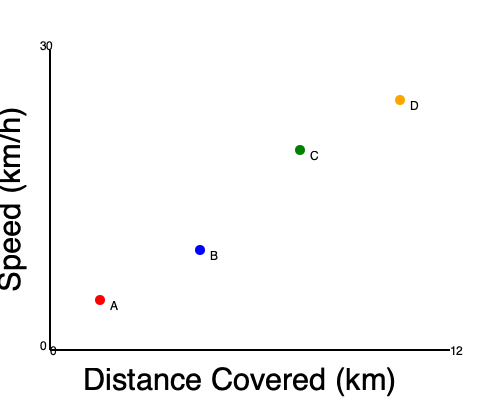Based on the scatter plot showing players' speed vs. distance covered during a match, which player is likely to be a midfielder with high endurance? To determine which player is likely to be a midfielder with high endurance, we need to analyze the relationship between speed and distance covered for each player:

1. Player A: Low speed, low distance covered
2. Player B: Moderate speed, moderate distance covered
3. Player C: High speed, high distance covered
4. Player D: Very high speed, very high distance covered

Midfielders typically need to cover large distances throughout the match while maintaining a good balance of speed. They require high endurance to continually move across the field, supporting both defense and attack.

Player C demonstrates a good balance of high speed and high distance covered, which aligns with the characteristics of a midfielder with high endurance. They cover more distance than players A and B, indicating better stamina, while maintaining a higher speed than A and B.

Player D, while covering the most distance at the highest speed, might be more indicative of a forward or winger who makes frequent sprints but may not consistently cover as much ground as a midfielder throughout the entire match.

Therefore, Player C is the most likely candidate for a midfielder with high endurance based on the given data.
Answer: Player C 